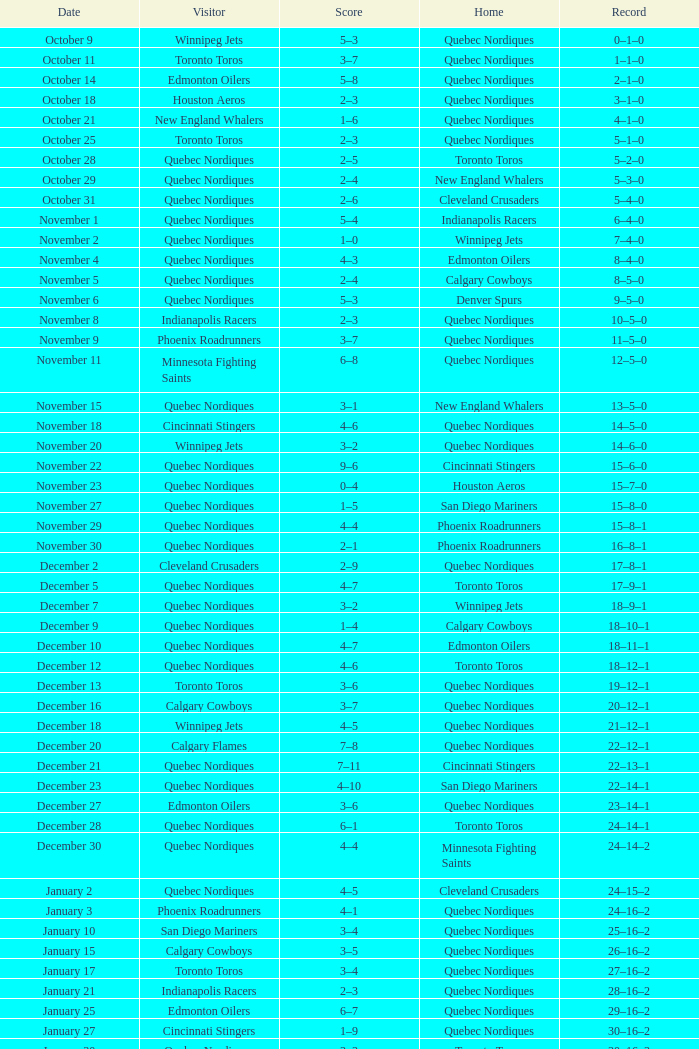What was the date of the game with a score of 2–1? November 30. 